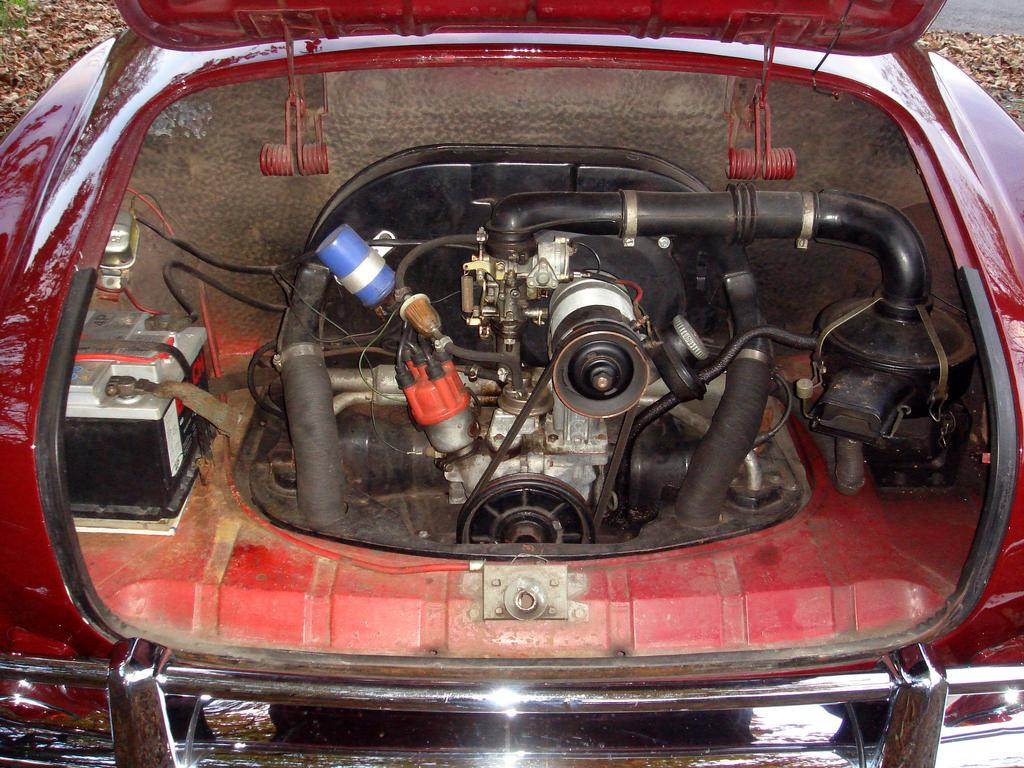What type of vehicle is in the image? There is a car in the image. What part of the car is visible in the image? The car is facing away from the viewer, so the back view is visible. What object is near the car in the image? There is an electrical instrument near the car. What type of environment is visible in the background of the image? There is land visible in the background of the image. What type of oven is visible in the image? There is no oven present in the image. How many feet can be seen in the image? There are no feet visible in the image. 